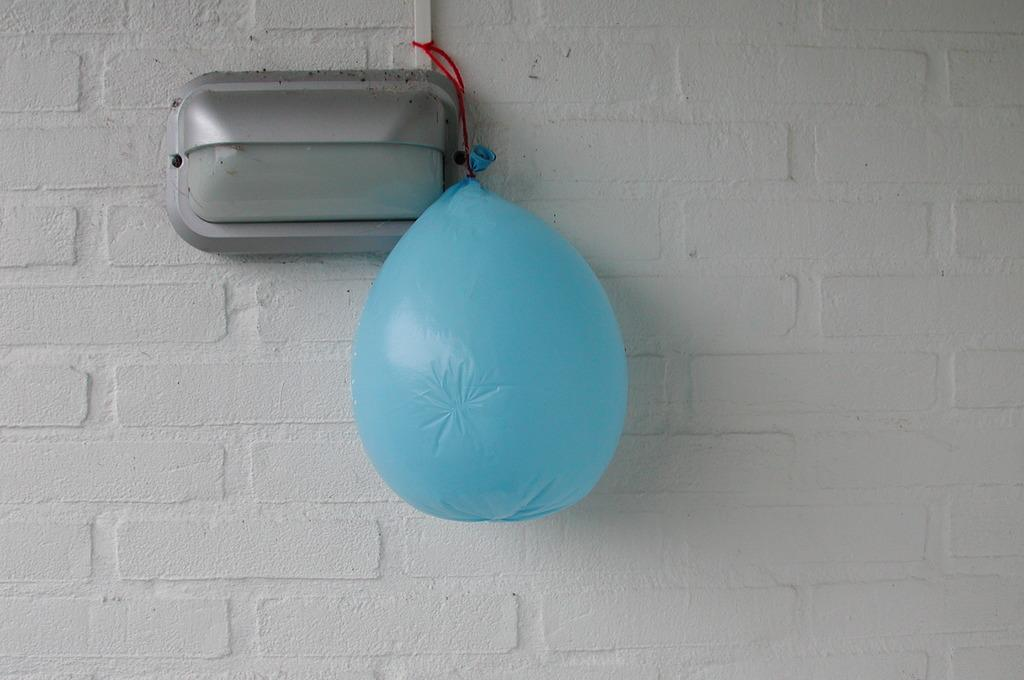What is present in the image that is typically filled with air? There is a balloon in the image. How is the balloon secured in the image? The balloon is tied to a pipe. What object can be seen attached to the wall in the image? There is a box attached to the wall in the image. Can you hear the guitar being played in the image? There is no guitar present in the image, so it cannot be heard being played. Does the balloon cause anyone in the image to cough? There is no coughing or reference to a cough in the image. 